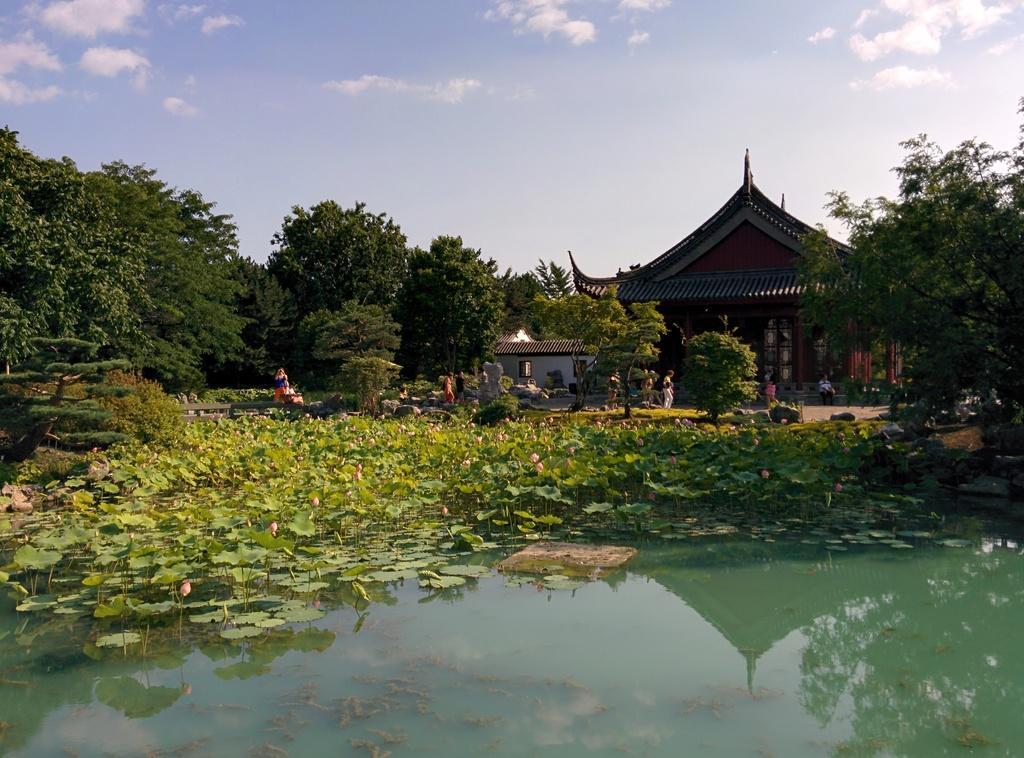Could you give a brief overview of what you see in this image? In this picture there are buildings and trees and there are group of people. At the top there is sky and there are clouds. At the bottom there are flowers, plants and there is water. 